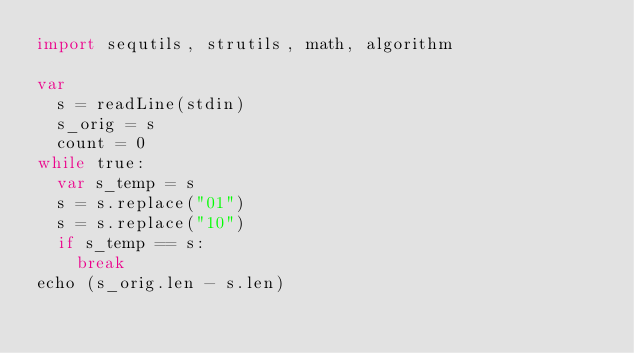<code> <loc_0><loc_0><loc_500><loc_500><_Nim_>import sequtils, strutils, math, algorithm

var
  s = readLine(stdin)
  s_orig = s
  count = 0
while true:
  var s_temp = s
  s = s.replace("01")
  s = s.replace("10")
  if s_temp == s:
    break
echo (s_orig.len - s.len)</code> 